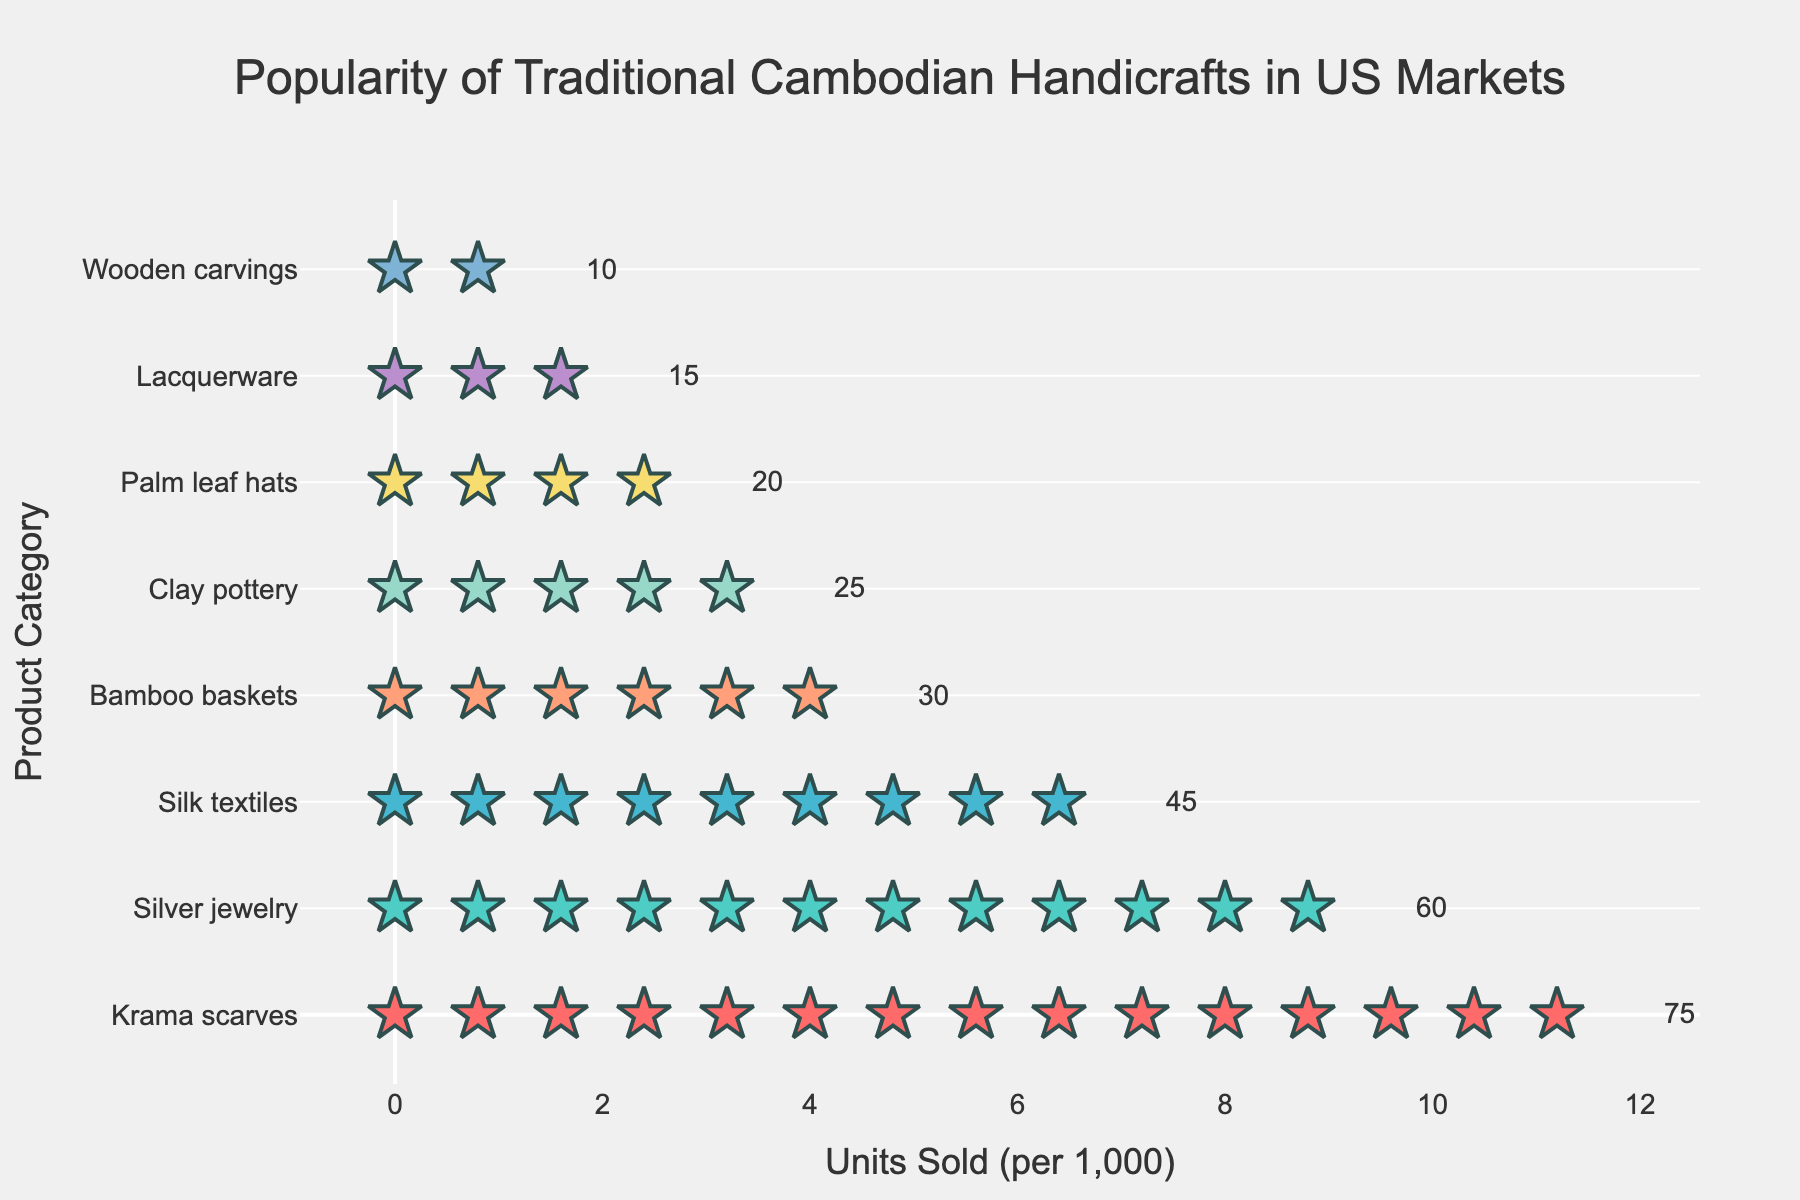What is the title of the figure? The title usually appears at the top of the figure and provides an overview of what the visualization is about. Here, it states the specific focus on Cambodian handicrafts in the US market.
Answer: Popularity of Traditional Cambodian Handicrafts in US Markets How many product categories are depicted in the figure? The y-axis labels each product category, providing a list that is easy to count. Each y-axis tick corresponds to a different product.
Answer: 8 Which product category has the highest units sold per 1,000? The product category with the most icons (stars) visually indicates the highest number of units sold per 1,000. The position of Krama scarves at the top with the most stars suggests it is the highest.
Answer: Krama scarves By how many units does the popularity of Silver Jewelry exceed Bamboo Baskets? Look at the annotations next to the stars indicating the units sold. Silver Jewelry has 60 units and Bamboo Baskets have 30 units. The difference is 60 - 30.
Answer: 30 units What is the least popular product category according to the figure? The product category with the fewest icons (stars) indicates the least popularity. Here, Wooden carvings have the fewest number of stars.
Answer: Wooden carvings What is the combined total of units sold per 1,000 for Silk Textiles and Silver Jewelry? Check the annotations next to the stars for both categories. Silk Textiles have 45 units sold per 1,000 and Silver Jewelry has 60. The combined total is 45 + 60.
Answer: 105 How many more units per 1,000 does Palm Leaf Hats have over Lacquerware? Compare the respective units sold per 1,000 from the annotations. Palm Leaf Hats have 20 units, and Lacquerware has 15 units. The difference is 20 - 15.
Answer: 5 units Which product categories have more than 40 units sold per 1,000? By looking at the annotations, the categories with more than 40 units are easily identified. Krama scarves (75), Silver jewelry (60), and Silk textiles (45) fit this criterion.
Answer: Krama scarves, Silver jewelry, Silk textiles What is the average number of units sold per 1,000 for all product categories? Sum the units sold for all categories and divide by the number of categories (75+60+45+30+25+20+15+10)/8. The total is 280, hence the average is 280/8.
Answer: 35 Which is more popular, Bamboo Baskets or Clay Pottery? Compare the number of stars for each category. Bamboo Baskets have 30 units sold per 1,000 while Clay Pottery has 25 units.
Answer: Bamboo Baskets 